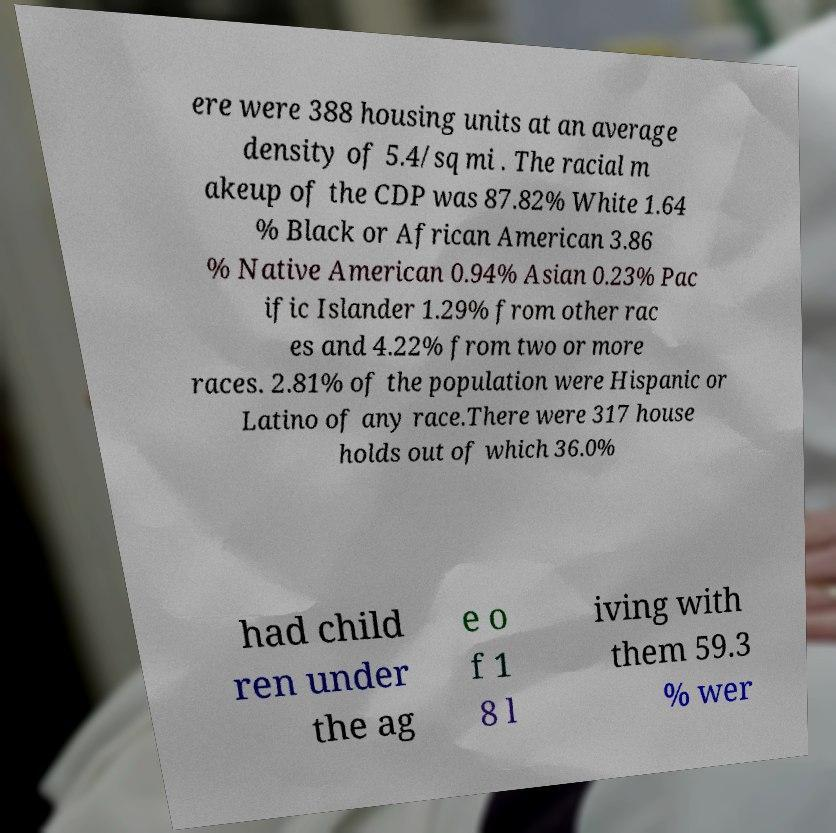Can you read and provide the text displayed in the image?This photo seems to have some interesting text. Can you extract and type it out for me? ere were 388 housing units at an average density of 5.4/sq mi . The racial m akeup of the CDP was 87.82% White 1.64 % Black or African American 3.86 % Native American 0.94% Asian 0.23% Pac ific Islander 1.29% from other rac es and 4.22% from two or more races. 2.81% of the population were Hispanic or Latino of any race.There were 317 house holds out of which 36.0% had child ren under the ag e o f 1 8 l iving with them 59.3 % wer 